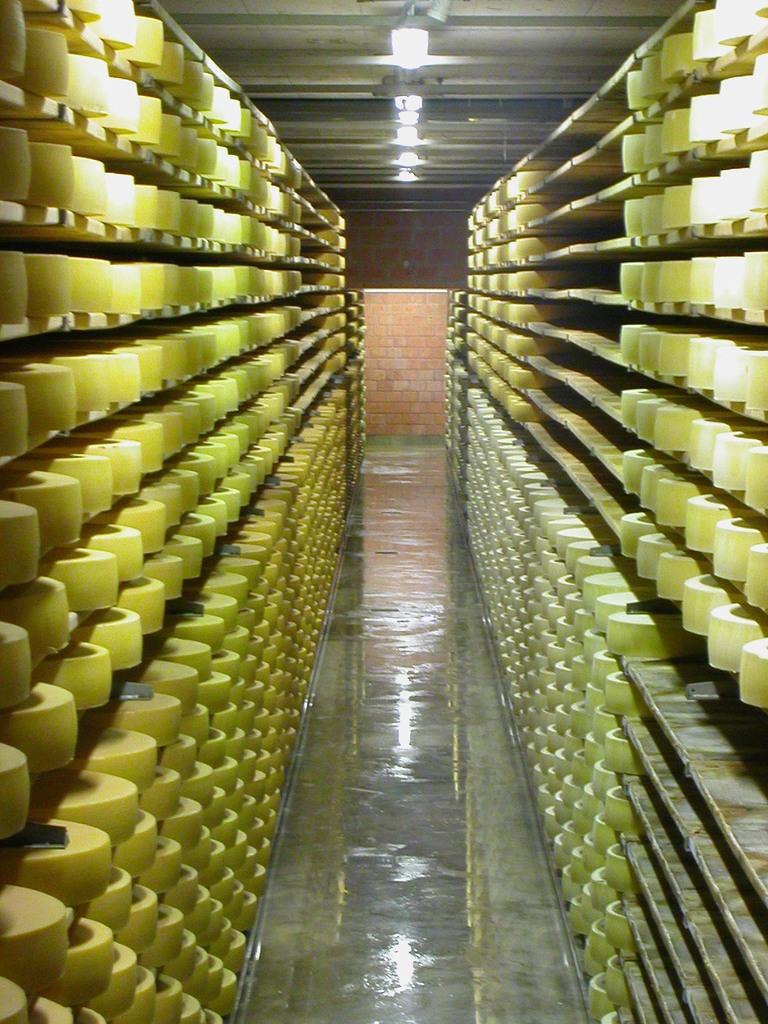What can be observed in the image? There are objects in the image. How are the objects arranged? The objects are arranged in rows. Can you compare the brightness of the lamp in the image to the brightness of the sun? There is no lamp present in the image, so it is not possible to compare its brightness to the brightness of the sun. 